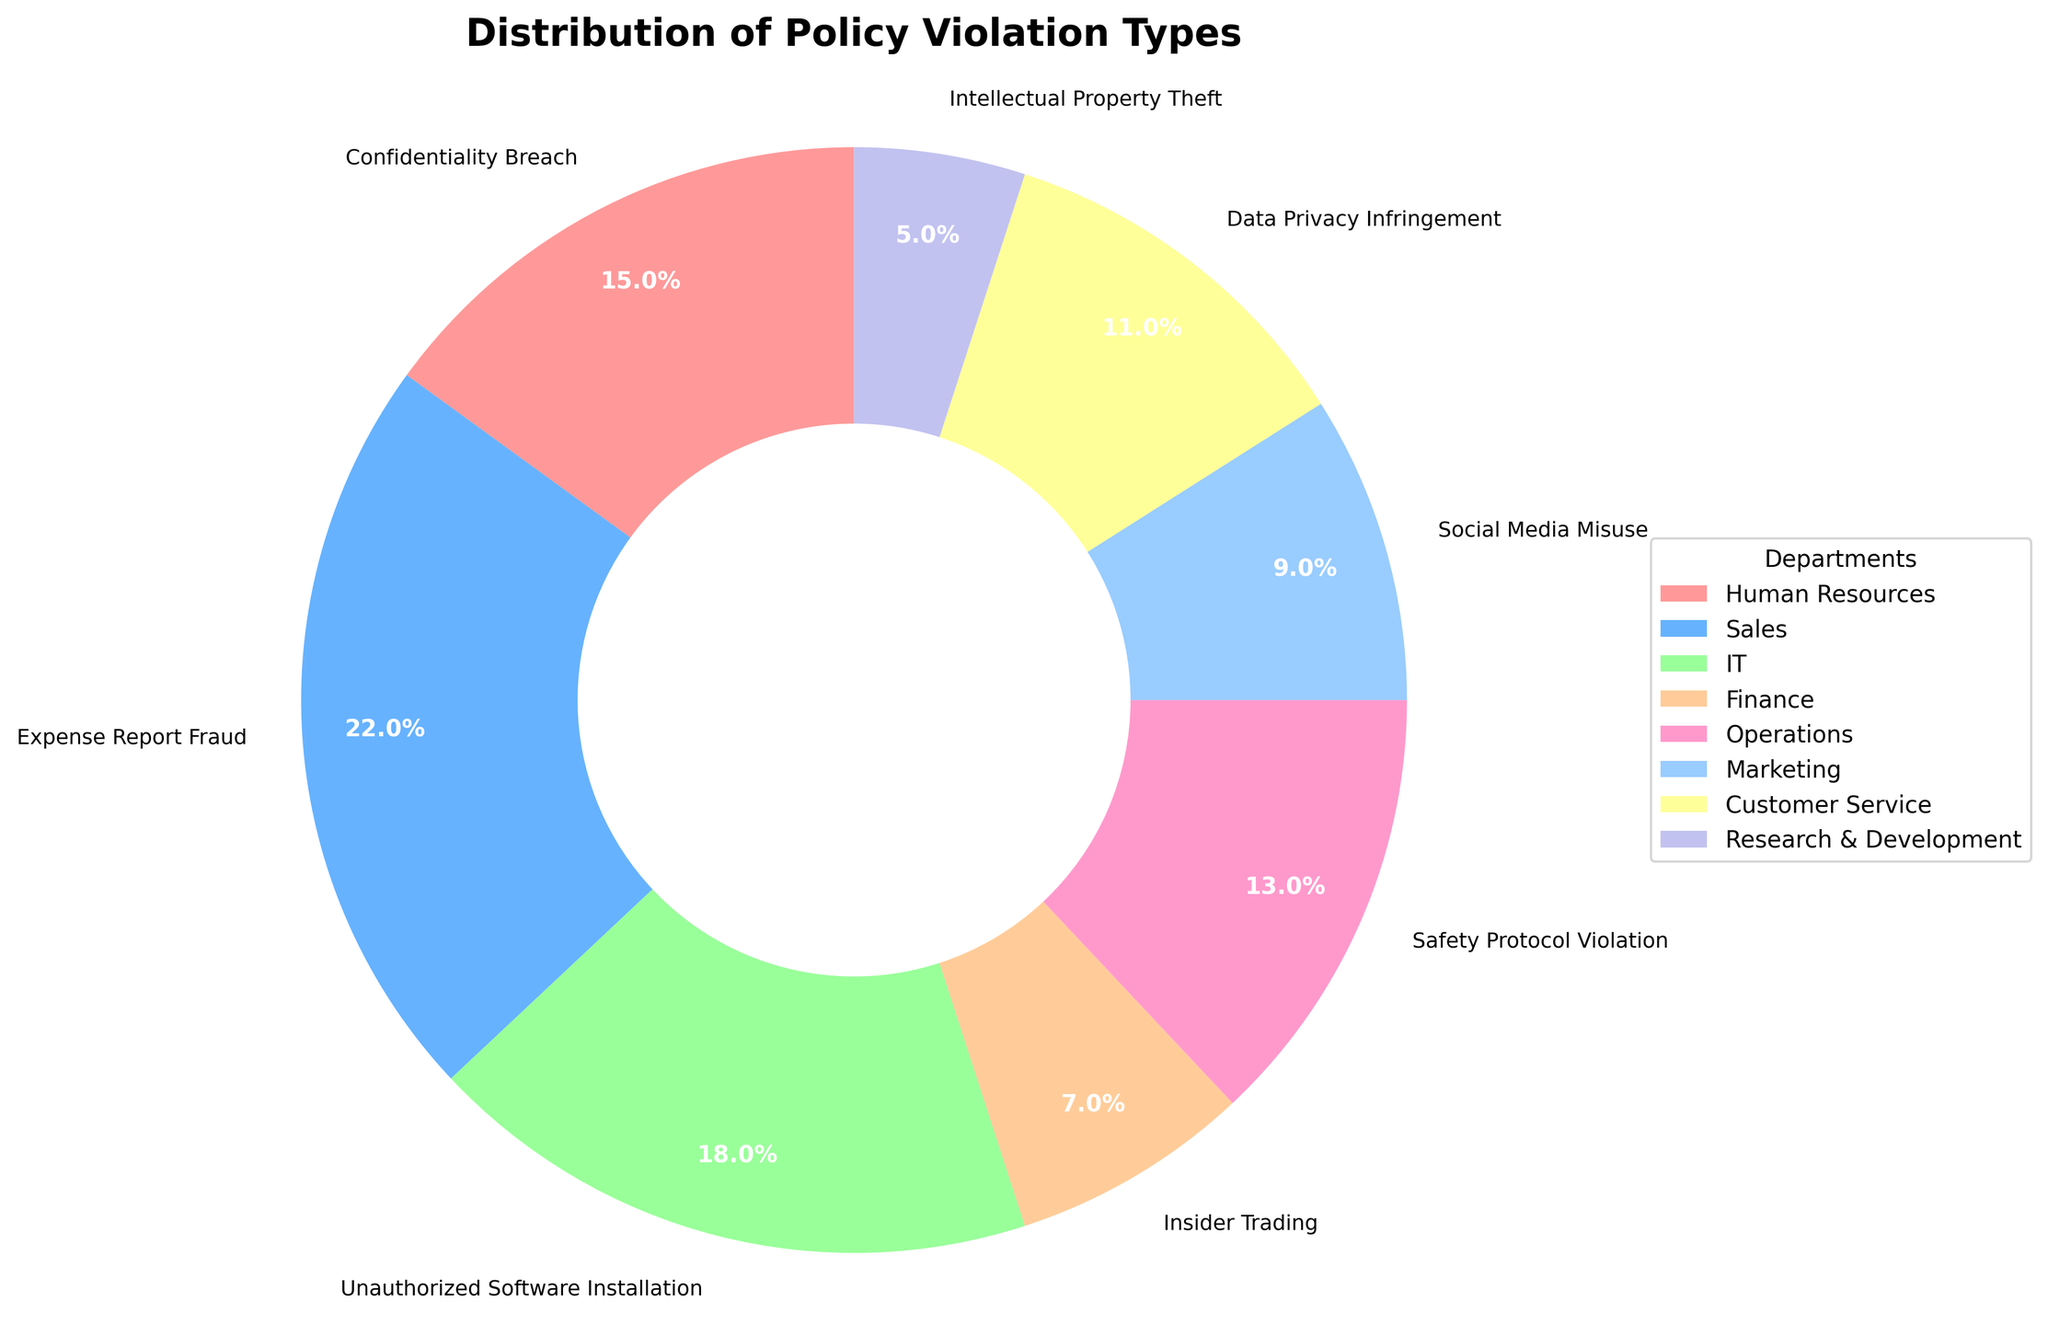Which department is most responsible for Expense Report Fraud? The pie chart shows the distribution of policy violations across departments. By identifying the section labeled "Expense Report Fraud," we can see that it corresponds to the Sales department with 22%.
Answer: Sales What is the total percentage of violations attributed to IT and Customer Service combined? Find the percentage values corresponding to IT (18%) and Customer Service (11%) and add them together: 18% + 11% = 29%.
Answer: 29% Which policy violation type has the smallest percentage representation? Looking at the pie chart, the smallest section corresponds to "Intellectual Property Theft" from the Research & Development department, which is 5%.
Answer: Intellectual Property Theft Are there more confidentiality breaches or safety protocol violations? The chart shows "Confidentiality Breach" at 15% and "Safety Protocol Violation" at 13%. Comparing these values, there are more confidentiality breaches.
Answer: Confidentiality Breach Which segment has the color red in the pie chart, and what violation does it represent? The colors of the pie chart segments are distinct. By identifying the red segment, we find that it represents "Confidentiality Breach" from the Human Resources department.
Answer: Confidentiality Breach How does the percentage of Social Media Misuse compare to that of Data Privacy Infringement? The pie chart shows "Social Media Misuse" at 9% and "Data Privacy Infringement" at 11%. By comparing these values, we see that "Data Privacy Infringement" is 2% higher.
Answer: Data Privacy Infringement is higher by 2% What is the difference in the percentage of violations between Finance and Operations departments? The pie chart shows the Finance department at 7% and the Operations department at 13%. The difference is calculated as 13% - 7% = 6%.
Answer: 6% What is the combined percentage of Confidentiality Breach and Intellectual Property Theft? Summing up the percentages for "Confidentiality Breach" (15%) and "Intellectual Property Theft" (5%) gives 15% + 5% = 20%.
Answer: 20% Which violation types are represented in the same colors as Expense Report Fraud? The color blue represents "Expense Report Fraud". Checking the chart visually reveals that no other sections share this exact color.
Answer: No other types Which departments have a percentage of policy violations greater than 10%? Identifying the sections with percentages greater than 10%: these are Sales (22%), IT (18%), Human Resources (15%), Operations (13%), and Customer Service (11%).
Answer: Sales, IT, Human Resources, Operations, Customer Service 